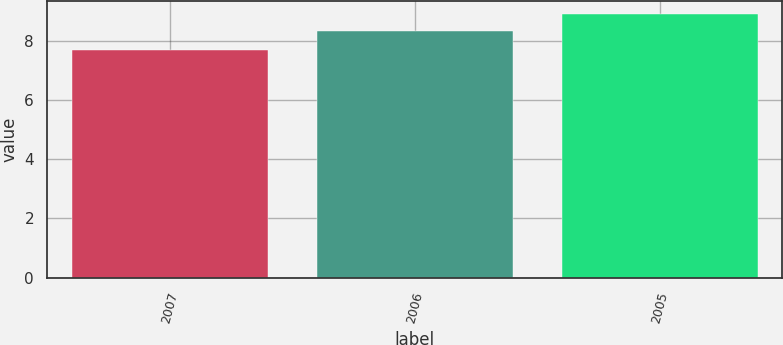Convert chart. <chart><loc_0><loc_0><loc_500><loc_500><bar_chart><fcel>2007<fcel>2006<fcel>2005<nl><fcel>7.67<fcel>8.32<fcel>8.9<nl></chart> 